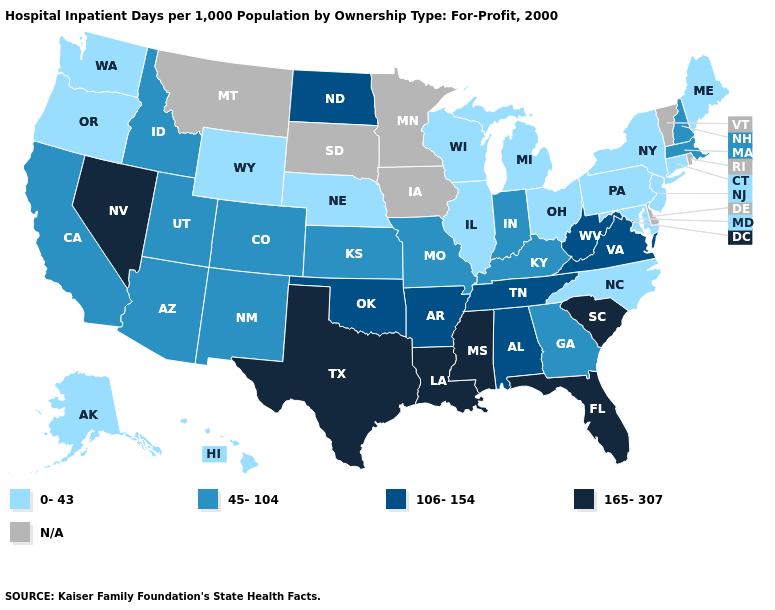Which states have the lowest value in the USA?
Concise answer only. Alaska, Connecticut, Hawaii, Illinois, Maine, Maryland, Michigan, Nebraska, New Jersey, New York, North Carolina, Ohio, Oregon, Pennsylvania, Washington, Wisconsin, Wyoming. Name the states that have a value in the range 45-104?
Give a very brief answer. Arizona, California, Colorado, Georgia, Idaho, Indiana, Kansas, Kentucky, Massachusetts, Missouri, New Hampshire, New Mexico, Utah. Among the states that border Wyoming , which have the lowest value?
Be succinct. Nebraska. Name the states that have a value in the range N/A?
Answer briefly. Delaware, Iowa, Minnesota, Montana, Rhode Island, South Dakota, Vermont. Among the states that border Indiana , which have the lowest value?
Concise answer only. Illinois, Michigan, Ohio. What is the value of Alaska?
Write a very short answer. 0-43. Name the states that have a value in the range 165-307?
Answer briefly. Florida, Louisiana, Mississippi, Nevada, South Carolina, Texas. What is the value of Wyoming?
Write a very short answer. 0-43. How many symbols are there in the legend?
Give a very brief answer. 5. What is the highest value in states that border Arkansas?
Write a very short answer. 165-307. Name the states that have a value in the range 0-43?
Short answer required. Alaska, Connecticut, Hawaii, Illinois, Maine, Maryland, Michigan, Nebraska, New Jersey, New York, North Carolina, Ohio, Oregon, Pennsylvania, Washington, Wisconsin, Wyoming. What is the value of Ohio?
Write a very short answer. 0-43. What is the value of Florida?
Keep it brief. 165-307. What is the lowest value in the MidWest?
Short answer required. 0-43. Among the states that border Oklahoma , which have the lowest value?
Concise answer only. Colorado, Kansas, Missouri, New Mexico. 